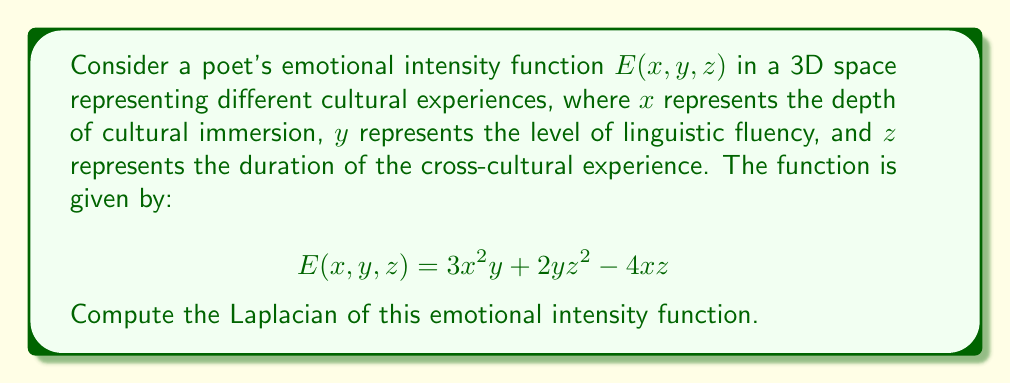Solve this math problem. To compute the Laplacian of the emotional intensity function $E(x,y,z)$, we need to follow these steps:

1. The Laplacian in 3D Cartesian coordinates is defined as:

   $$\nabla^2 E = \frac{\partial^2 E}{\partial x^2} + \frac{\partial^2 E}{\partial y^2} + \frac{\partial^2 E}{\partial z^2}$$

2. Let's calculate each second partial derivative:

   a. $\frac{\partial^2 E}{\partial x^2}$:
      First, $\frac{\partial E}{\partial x} = 6xy - 4z$
      Then, $\frac{\partial^2 E}{\partial x^2} = 6y$

   b. $\frac{\partial^2 E}{\partial y^2}$:
      First, $\frac{\partial E}{\partial y} = 3x^2 + 2z^2$
      Then, $\frac{\partial^2 E}{\partial y^2} = 0$

   c. $\frac{\partial^2 E}{\partial z^2}$:
      First, $\frac{\partial E}{\partial z} = 4yz - 4x$
      Then, $\frac{\partial^2 E}{\partial z^2} = 4y$

3. Now, we sum these second partial derivatives:

   $$\nabla^2 E = \frac{\partial^2 E}{\partial x^2} + \frac{\partial^2 E}{\partial y^2} + \frac{\partial^2 E}{\partial z^2}$$
   $$\nabla^2 E = 6y + 0 + 4y$$
   $$\nabla^2 E = 10y$$

Therefore, the Laplacian of the emotional intensity function is $10y$.
Answer: $10y$ 